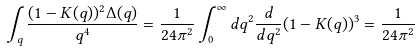<formula> <loc_0><loc_0><loc_500><loc_500>\int _ { q } \frac { ( 1 - K ( q ) ) ^ { 2 } \Delta ( q ) } { q ^ { 4 } } = \frac { 1 } { 2 4 \pi ^ { 2 } } \int _ { 0 } ^ { \infty } d q ^ { 2 } \frac { d } { d q ^ { 2 } } ( 1 - K ( q ) ) ^ { 3 } = \frac { 1 } { 2 4 \pi ^ { 2 } }</formula> 